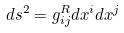<formula> <loc_0><loc_0><loc_500><loc_500>d s ^ { 2 } = g _ { i j } ^ { R } d x ^ { i } d x ^ { j }</formula> 